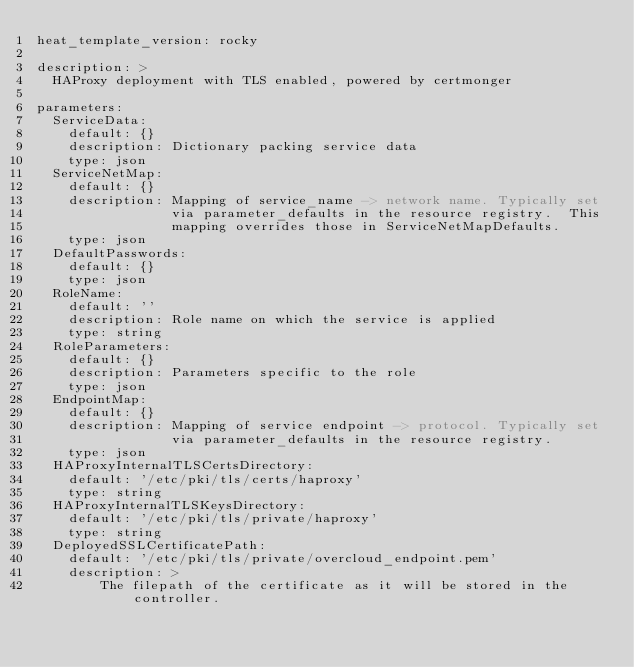Convert code to text. <code><loc_0><loc_0><loc_500><loc_500><_YAML_>heat_template_version: rocky

description: >
  HAProxy deployment with TLS enabled, powered by certmonger

parameters:
  ServiceData:
    default: {}
    description: Dictionary packing service data
    type: json
  ServiceNetMap:
    default: {}
    description: Mapping of service_name -> network name. Typically set
                 via parameter_defaults in the resource registry.  This
                 mapping overrides those in ServiceNetMapDefaults.
    type: json
  DefaultPasswords:
    default: {}
    type: json
  RoleName:
    default: ''
    description: Role name on which the service is applied
    type: string
  RoleParameters:
    default: {}
    description: Parameters specific to the role
    type: json
  EndpointMap:
    default: {}
    description: Mapping of service endpoint -> protocol. Typically set
                 via parameter_defaults in the resource registry.
    type: json
  HAProxyInternalTLSCertsDirectory:
    default: '/etc/pki/tls/certs/haproxy'
    type: string
  HAProxyInternalTLSKeysDirectory:
    default: '/etc/pki/tls/private/haproxy'
    type: string
  DeployedSSLCertificatePath:
    default: '/etc/pki/tls/private/overcloud_endpoint.pem'
    description: >
        The filepath of the certificate as it will be stored in the controller.</code> 